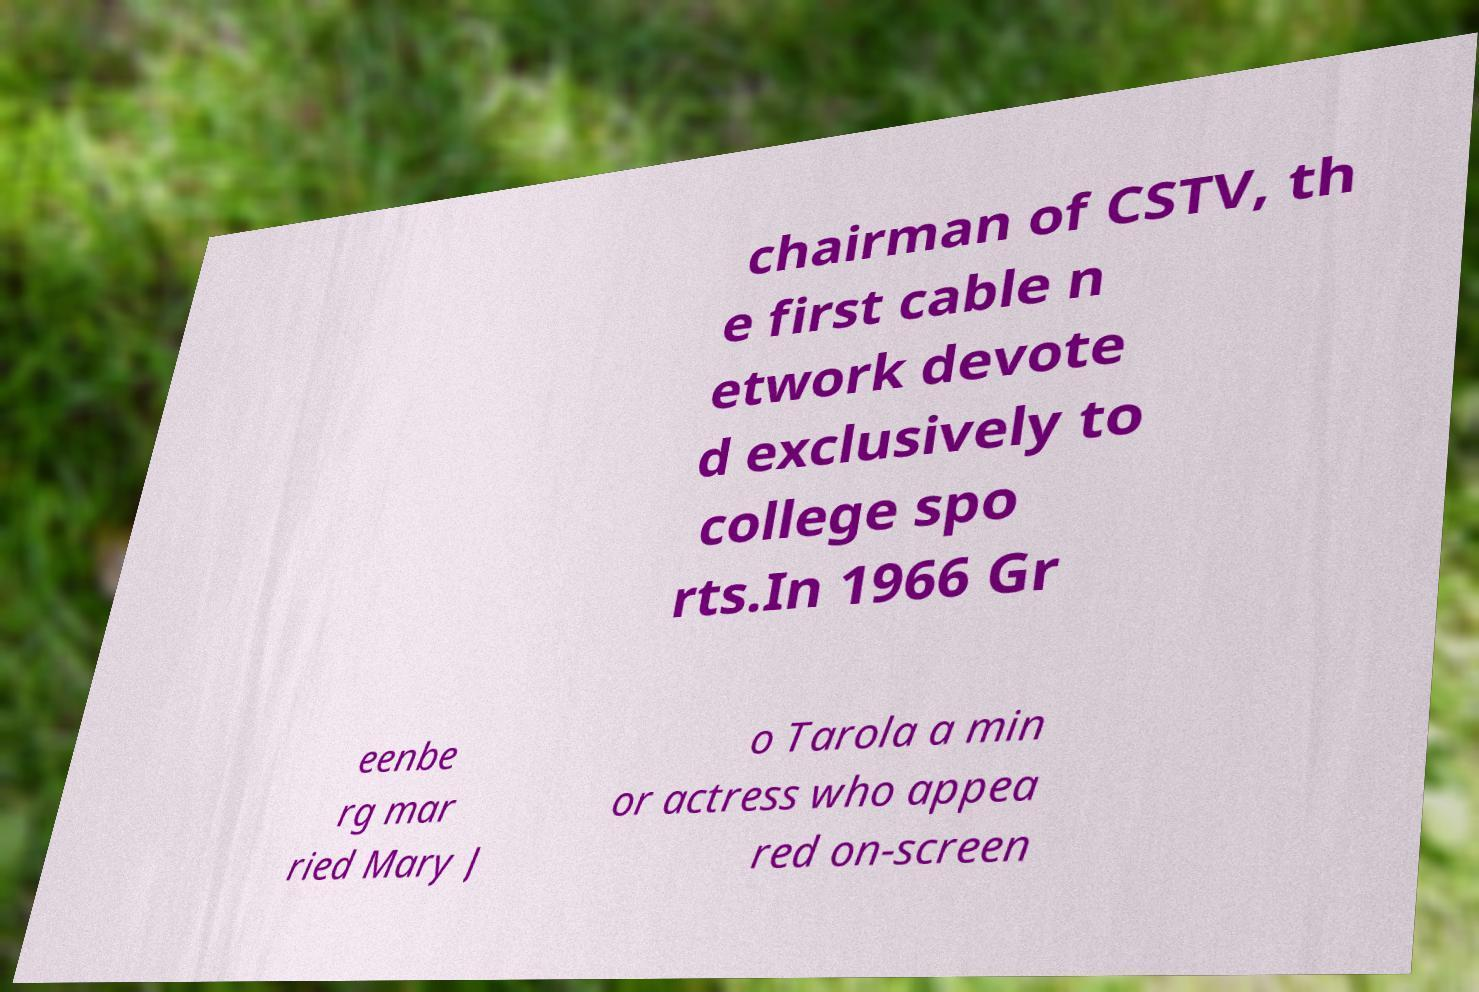Please identify and transcribe the text found in this image. chairman of CSTV, th e first cable n etwork devote d exclusively to college spo rts.In 1966 Gr eenbe rg mar ried Mary J o Tarola a min or actress who appea red on-screen 